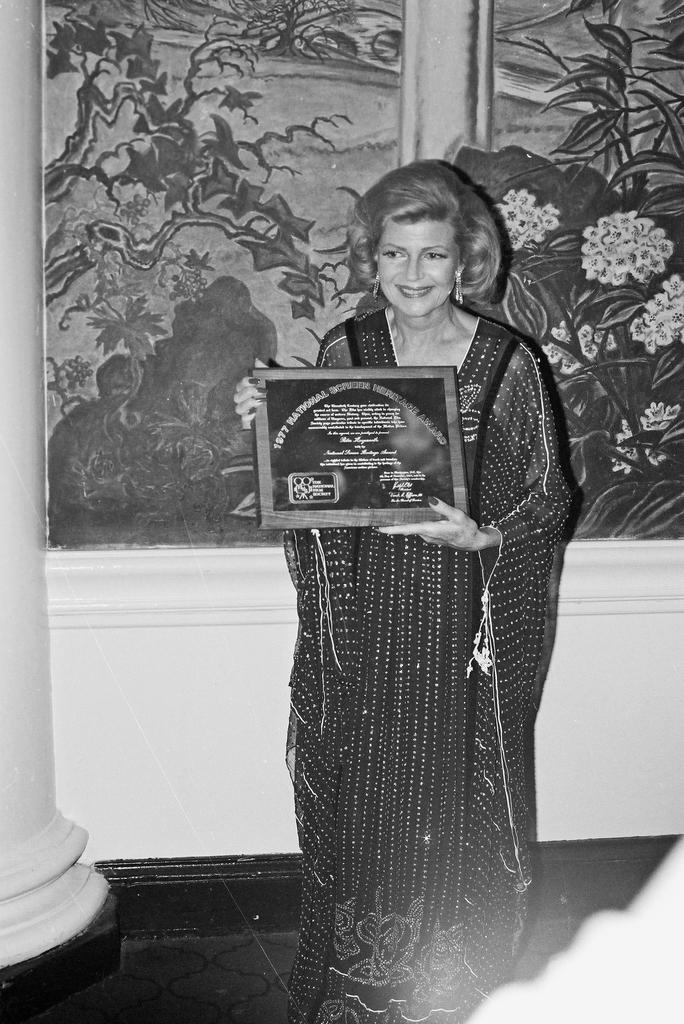What is the color scheme of the image? The image is black and white. Who is present in the image? There is a woman in the image. What is the woman holding in her hands? The woman is holding an award in her hands. What can be seen in the background of the image? There is a wall in the background of the image, and there is a painting on the wall. Can you tell me where the kitty is hiding in the image? There is no kitty present in the image. What causes the burst of colors in the image? The image is black and white, so there is no burst of colors. 